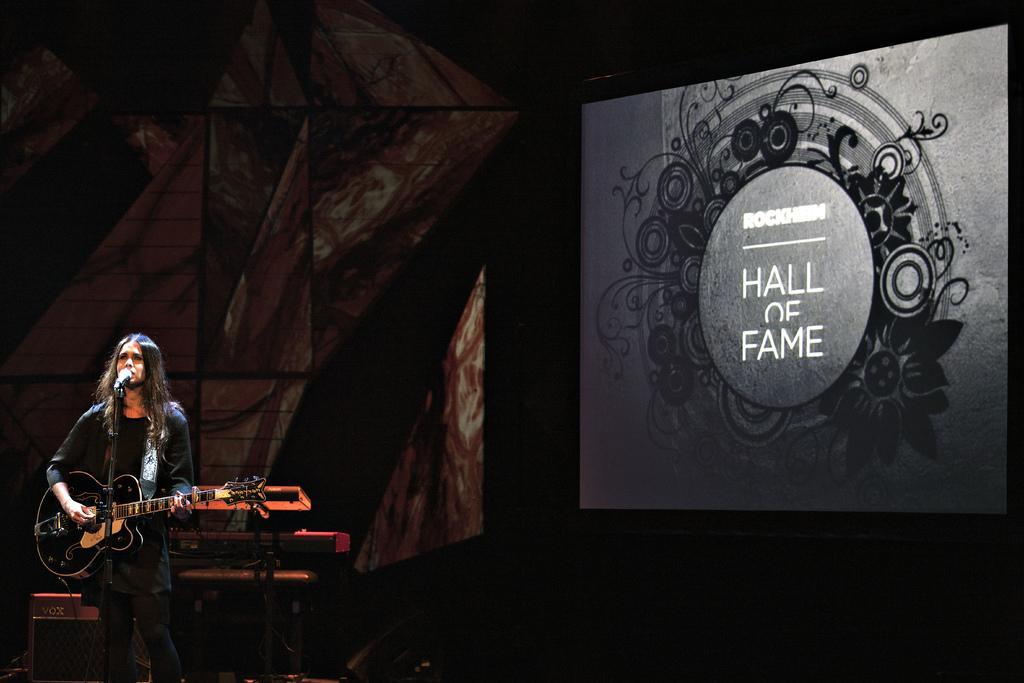In one or two sentences, can you explain what this image depicts? In this image I can see a woman is standing and holding a guitar. I can also see a mic in front of her. In the background I can see a screen where HALL OF FAME is written. 